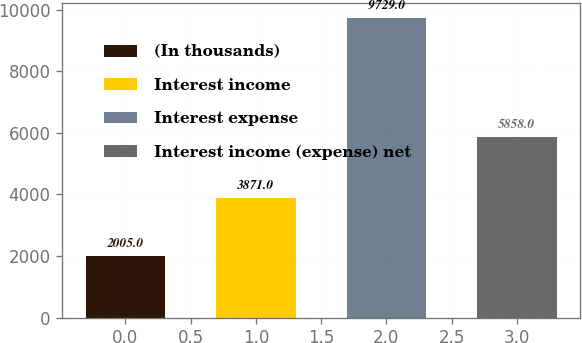Convert chart. <chart><loc_0><loc_0><loc_500><loc_500><bar_chart><fcel>(In thousands)<fcel>Interest income<fcel>Interest expense<fcel>Interest income (expense) net<nl><fcel>2005<fcel>3871<fcel>9729<fcel>5858<nl></chart> 